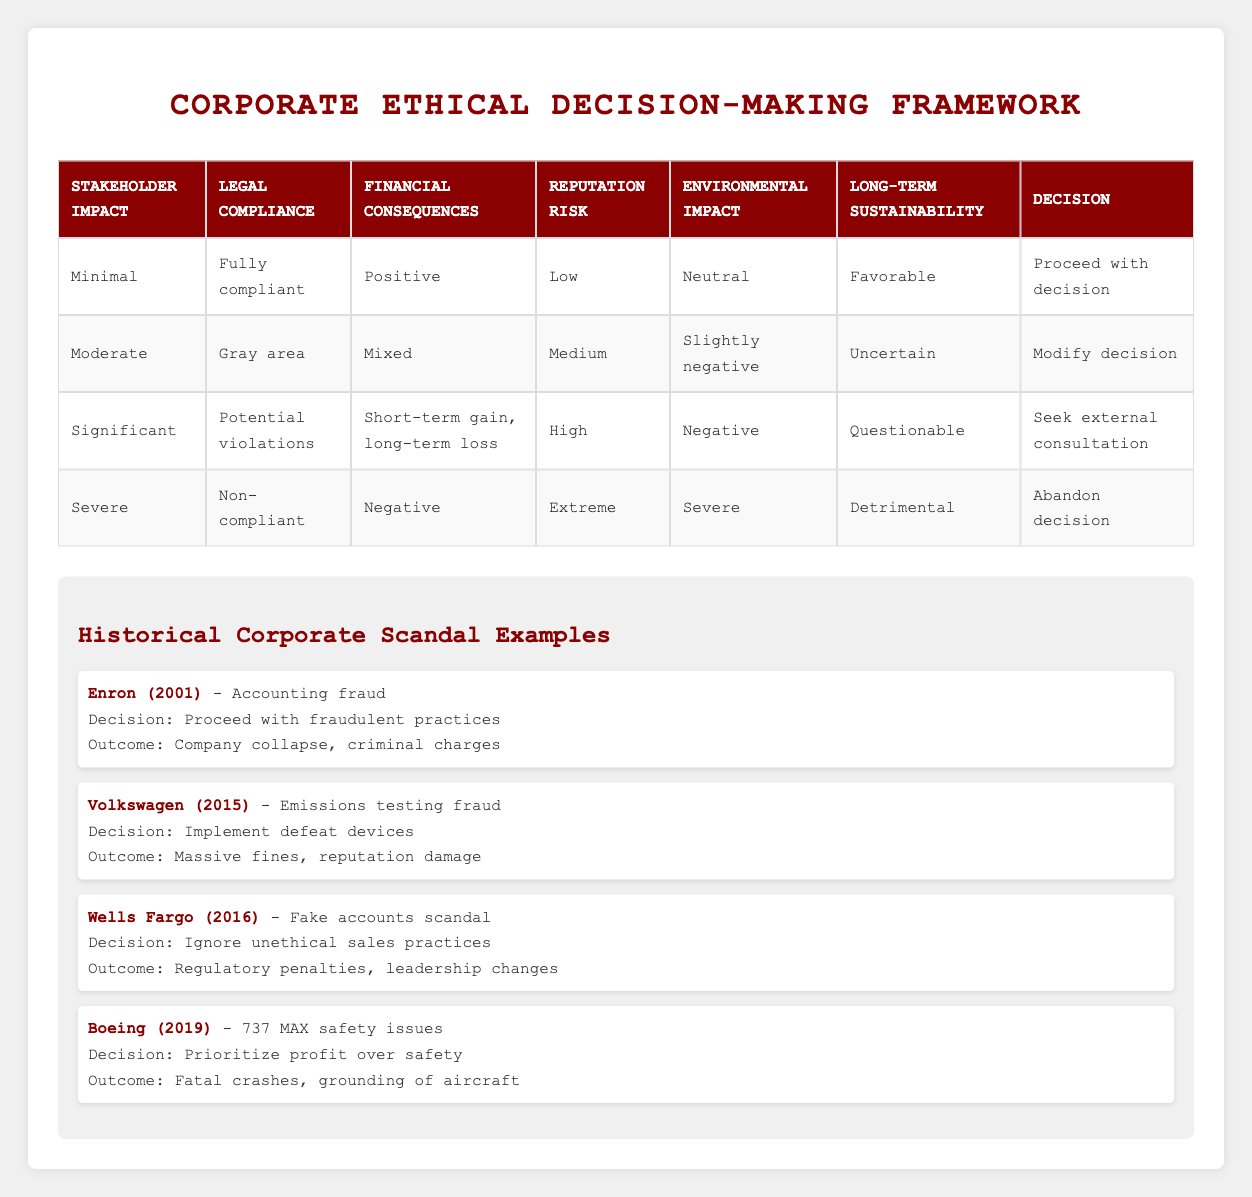What decision is recommended if stakeholder impact is minimal and legal compliance is fully compliant? According to the table, when stakeholder impact is minimal and legal compliance is fully compliant, the recommended decision is to "Proceed with decision." This can be directly found in the first row of the table.
Answer: Proceed with decision What is the reputation risk associated with a decision that involves potential legal violations? The table shows that for situations with potential legal violations (the row for significant stakeholder impact), the reputation risk is categorized as "High." This is in the third row of the table.
Answer: High Based on the table, if a company's financial consequences are mixed, what should they consider doing? The second row of the table indicates that with mixed financial consequences, the decision should be to "Modify decision." Therefore, this is the recommended course of action in such a situation.
Answer: Modify decision Is it true that a severe stakeholder impact always leads to abandoning the decision? Yes, this is true. The table clearly indicates that in situations where stakeholder impact is categorized as severe, the recommended decision is to "Abandon decision." This corresponds to the last row of the table.
Answer: Yes What is the overall decision when the environmental impact is negative and legal compliance is a gray area? To answer this, we look for a row where the environmental impact is negative and the legal compliance is a gray area. This corresponds to the third row of the table, which recommends seeking external consultation as the decision.
Answer: Seek external consultation If a company wants to postpone a decision, which conditions would apply based on the table? The table does not explicitly mention conditions that lead to delaying a decision. However, it associates the most severe considerations (like non-compliance and significant stakeholder impact leading to abandoning) with seeking external consultation or abandonment. Therefore, a decision to delay would be indicated in a situation that highlights uncertainty, as shown in the second row with "Uncertain" for long-term sustainability. This indicates a less severe option but does not predict delay specifically.
Answer: No specific conditions; related to uncertainty What are the conditions under which a company would proceed with a decision despite negative environmental impact? The table specifies that a company can proceed with a decision when stakeholder impact is minimal, legal compliance is fully compliant, and the overall impact on sustainability is favorable. This indicates a scenario where additional negative factors, such as adverse environmental impact, are not sufficient to prompt re-evaluation. Thus, these key conditions must be present to continue without reconsideration.
Answer: Minimal impact, fully compliant, favorable sustainability How many conditions are classified as severe in the table? The table outlines six conditions: Stakeholder impact, Legal compliance, Financial consequences, Reputation risk, Environmental impact, and Long-term sustainability. Among these, only "Severe" is explicitly mentioned for stakeholder impact in the last rule, with others being categorized differently.
Answer: One condition classified as severe 